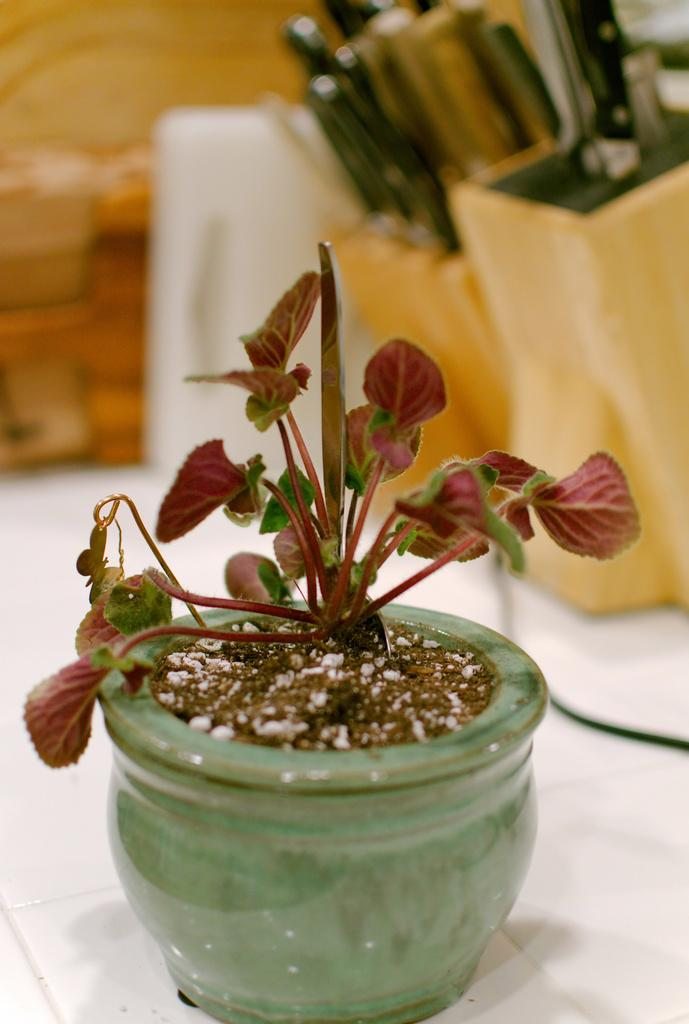What is the main feature in the center of the image? There is a platform in the center of the image. What is placed on the platform? There is a pot with a plant on the platform, as well as an unspecified object. Can you describe the background of the image? The background of the image is blurred. What type of nose can be seen on the plant in the image? There is no nose present on the plant in the image, as plants do not have noses. 